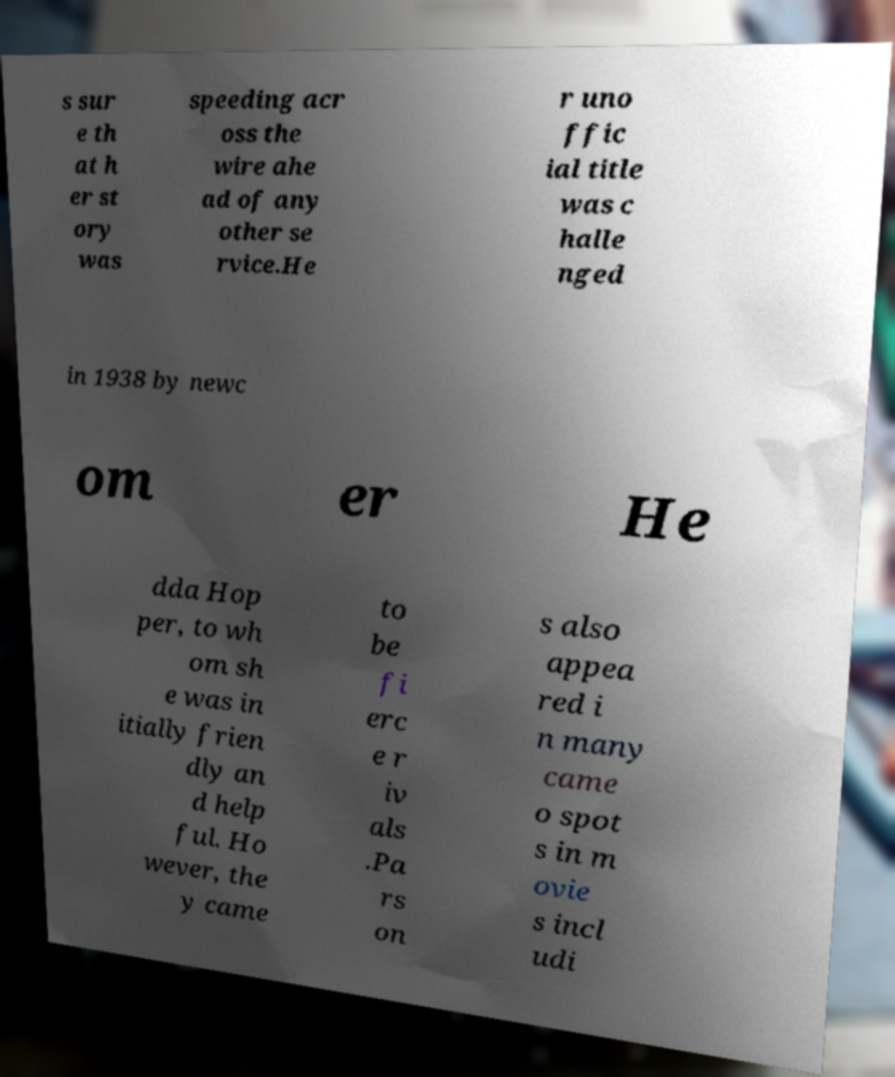Please identify and transcribe the text found in this image. s sur e th at h er st ory was speeding acr oss the wire ahe ad of any other se rvice.He r uno ffic ial title was c halle nged in 1938 by newc om er He dda Hop per, to wh om sh e was in itially frien dly an d help ful. Ho wever, the y came to be fi erc e r iv als .Pa rs on s also appea red i n many came o spot s in m ovie s incl udi 